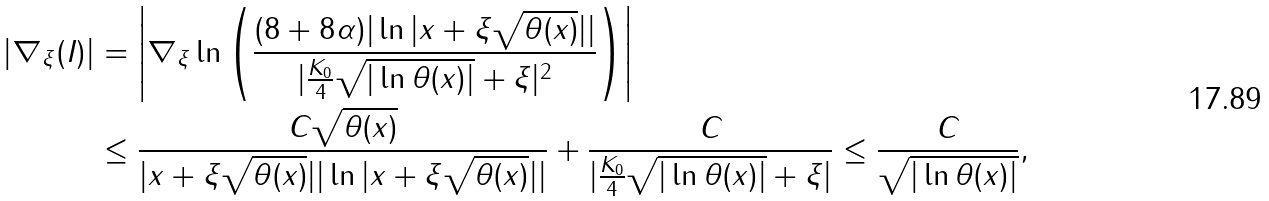<formula> <loc_0><loc_0><loc_500><loc_500>| \nabla _ { \xi } ( I ) | & = \left | \nabla _ { \xi } \ln \left ( \frac { ( 8 + 8 \alpha ) | \ln | x + \xi \sqrt { \theta ( x ) } | | } { | \frac { K _ { 0 } } { 4 } \sqrt { | \ln \theta ( x ) | } + \xi | ^ { 2 } } \right ) \right | \\ & \leq \frac { C \sqrt { \theta ( x ) } } { | x + \xi \sqrt { \theta ( x ) } | | \ln | x + \xi \sqrt { \theta ( x ) } | | } + \frac { C } { | \frac { K _ { 0 } } { 4 } \sqrt { | \ln \theta ( x ) | } + \xi | } \leq \frac { C } { \sqrt { | \ln \theta ( x ) | } } ,</formula> 